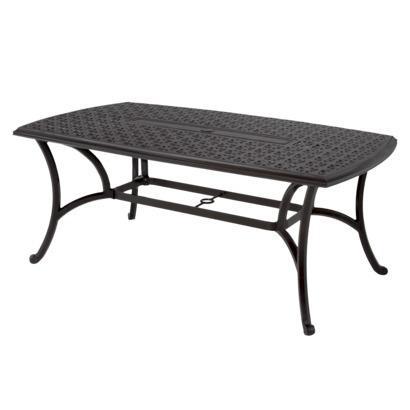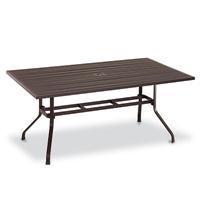The first image is the image on the left, the second image is the image on the right. For the images displayed, is the sentence "There is a concrete floor visible." factually correct? Answer yes or no. No. The first image is the image on the left, the second image is the image on the right. For the images displayed, is the sentence "In one image, a rectangular wooden table has two long bench seats, one on each side." factually correct? Answer yes or no. No. 